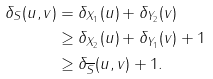Convert formula to latex. <formula><loc_0><loc_0><loc_500><loc_500>\delta _ { S } ( u , v ) & = \delta _ { X _ { 1 } } ( u ) + \delta _ { Y _ { 2 } } ( v ) \\ & \geq \delta _ { X _ { 2 } } ( u ) + \delta _ { Y _ { 1 } } ( v ) + 1 \\ & \geq \delta _ { \overline { S } } ( u , v ) + 1 .</formula> 